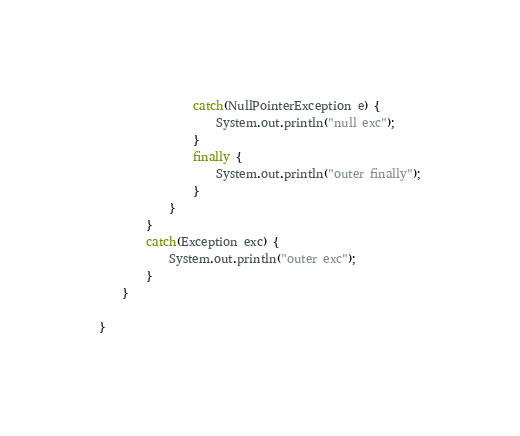Convert code to text. <code><loc_0><loc_0><loc_500><loc_500><_Java_>                catch(NullPointerException e) {
                    System.out.println("null exc");
                }
                finally {
                    System.out.println("outer finally");
                }
            }
        }
        catch(Exception exc) {
            System.out.println("outer exc");
        }
    }

}
</code> 